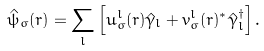Convert formula to latex. <formula><loc_0><loc_0><loc_500><loc_500>\hat { \psi } _ { \sigma } ( { r } ) = \sum _ { l } \left [ u _ { \sigma } ^ { l } ( { r } ) \hat { \gamma } _ { l } + v _ { \sigma } ^ { l } ( { r } ) ^ { * } \hat { \gamma } _ { l } ^ { \dagger } \right ] .</formula> 